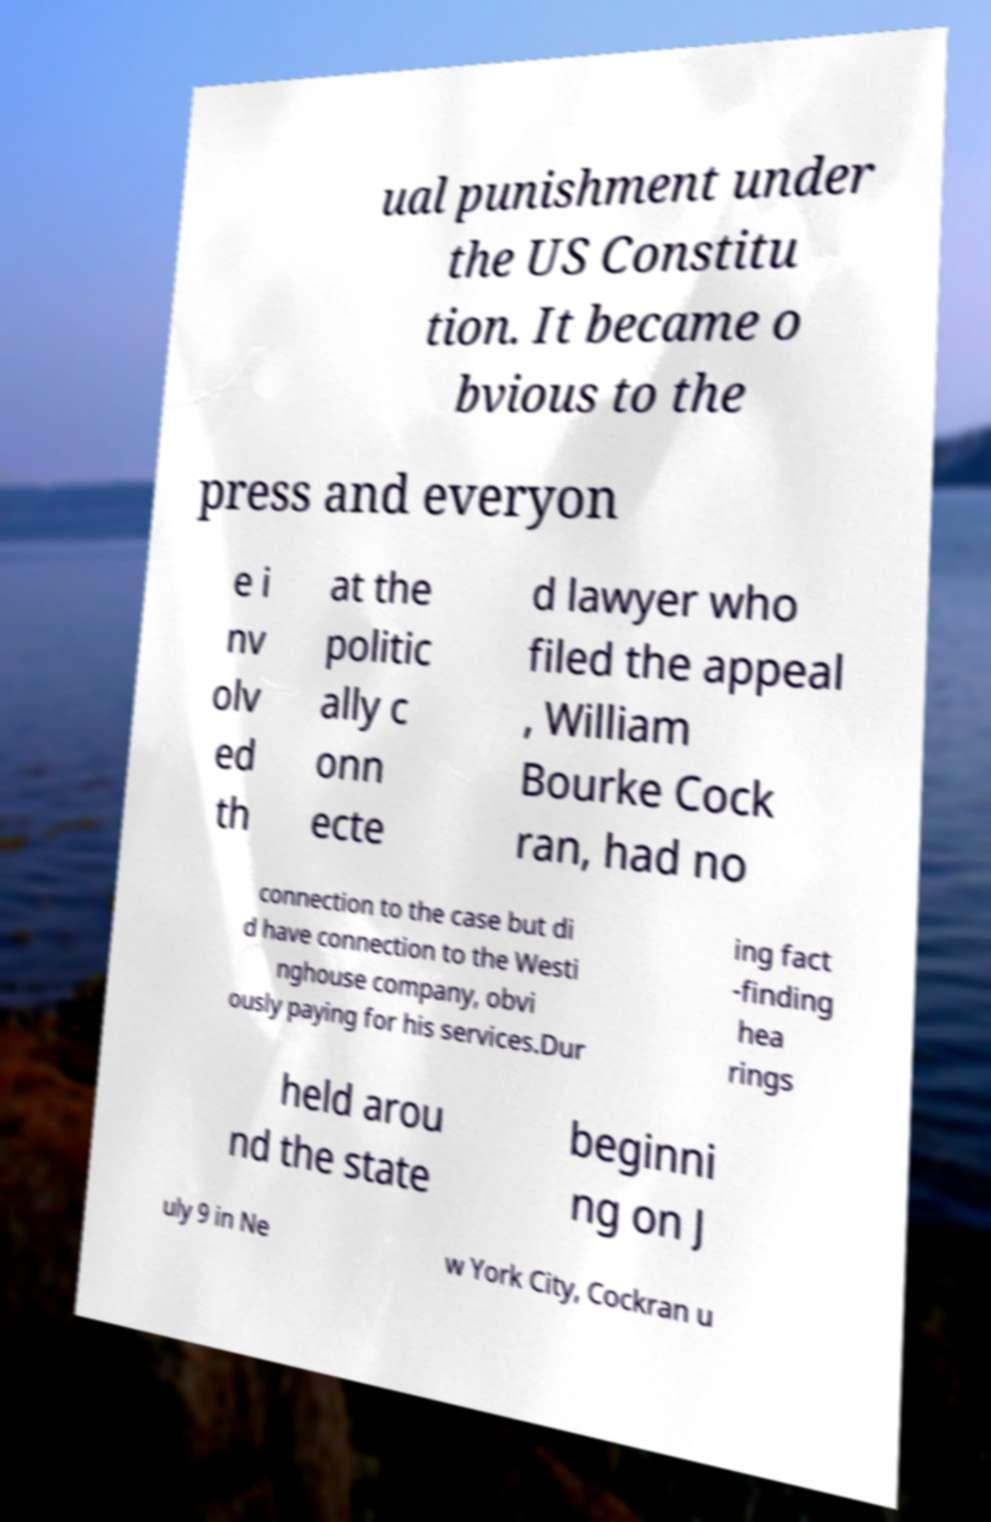For documentation purposes, I need the text within this image transcribed. Could you provide that? ual punishment under the US Constitu tion. It became o bvious to the press and everyon e i nv olv ed th at the politic ally c onn ecte d lawyer who filed the appeal , William Bourke Cock ran, had no connection to the case but di d have connection to the Westi nghouse company, obvi ously paying for his services.Dur ing fact -finding hea rings held arou nd the state beginni ng on J uly 9 in Ne w York City, Cockran u 